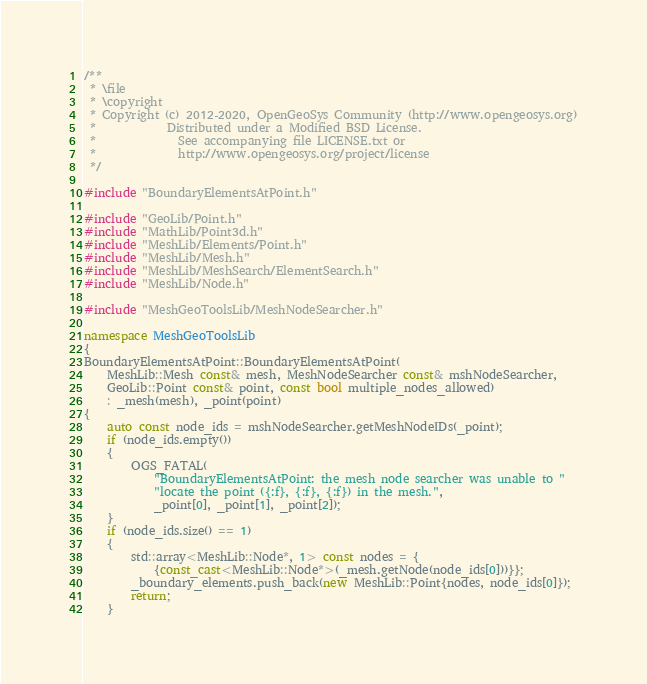Convert code to text. <code><loc_0><loc_0><loc_500><loc_500><_C++_>/**
 * \file
 * \copyright
 * Copyright (c) 2012-2020, OpenGeoSys Community (http://www.opengeosys.org)
 *            Distributed under a Modified BSD License.
 *              See accompanying file LICENSE.txt or
 *              http://www.opengeosys.org/project/license
 */

#include "BoundaryElementsAtPoint.h"

#include "GeoLib/Point.h"
#include "MathLib/Point3d.h"
#include "MeshLib/Elements/Point.h"
#include "MeshLib/Mesh.h"
#include "MeshLib/MeshSearch/ElementSearch.h"
#include "MeshLib/Node.h"

#include "MeshGeoToolsLib/MeshNodeSearcher.h"

namespace MeshGeoToolsLib
{
BoundaryElementsAtPoint::BoundaryElementsAtPoint(
    MeshLib::Mesh const& mesh, MeshNodeSearcher const& mshNodeSearcher,
    GeoLib::Point const& point, const bool multiple_nodes_allowed)
    : _mesh(mesh), _point(point)
{
    auto const node_ids = mshNodeSearcher.getMeshNodeIDs(_point);
    if (node_ids.empty())
    {
        OGS_FATAL(
            "BoundaryElementsAtPoint: the mesh node searcher was unable to "
            "locate the point ({:f}, {:f}, {:f}) in the mesh.",
            _point[0], _point[1], _point[2]);
    }
    if (node_ids.size() == 1)
    {
        std::array<MeshLib::Node*, 1> const nodes = {
            {const_cast<MeshLib::Node*>(_mesh.getNode(node_ids[0]))}};
        _boundary_elements.push_back(new MeshLib::Point{nodes, node_ids[0]});
        return;
    }
</code> 